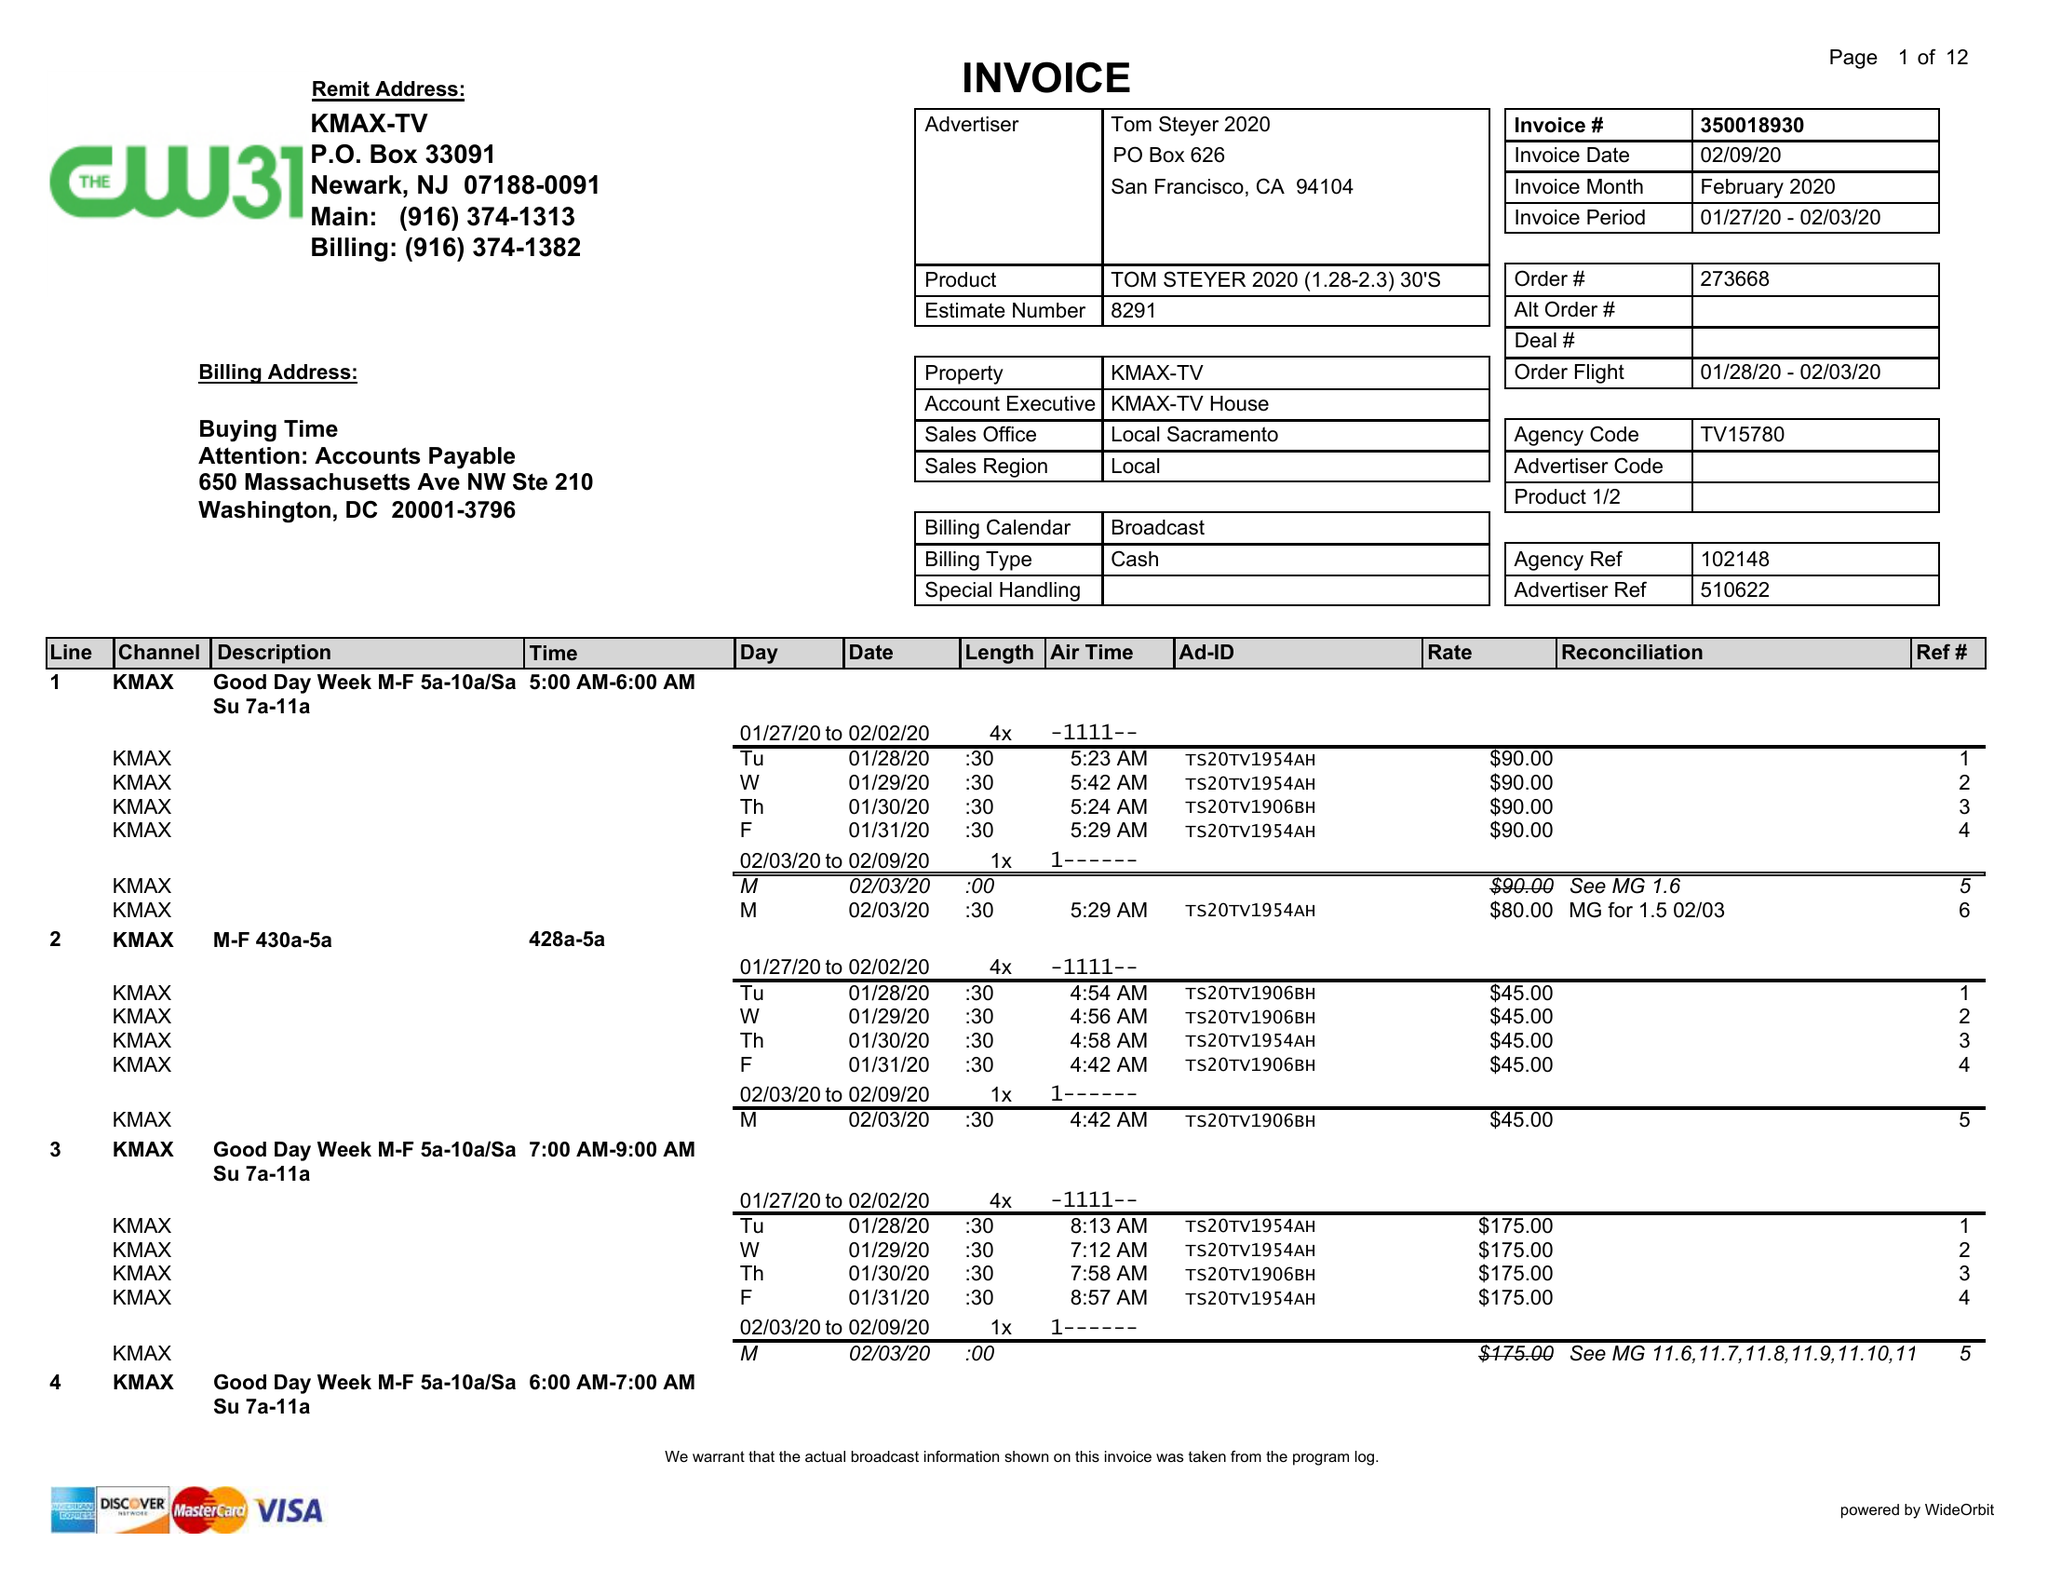What is the value for the contract_num?
Answer the question using a single word or phrase. 273668 